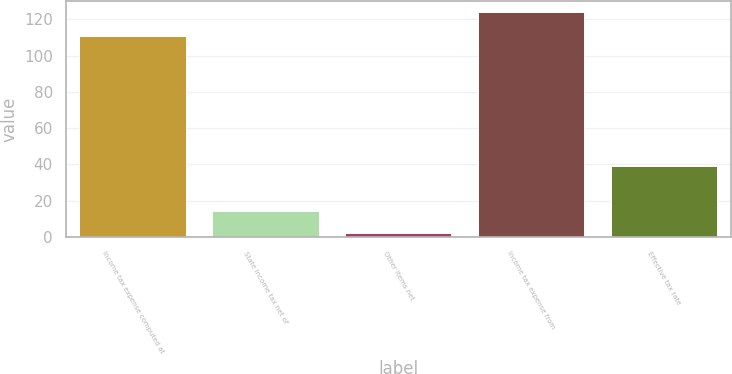<chart> <loc_0><loc_0><loc_500><loc_500><bar_chart><fcel>Income tax expense computed at<fcel>State income tax net of<fcel>Other items net<fcel>Income tax expense from<fcel>Effective tax rate<nl><fcel>111<fcel>14.2<fcel>2<fcel>124<fcel>39.1<nl></chart> 